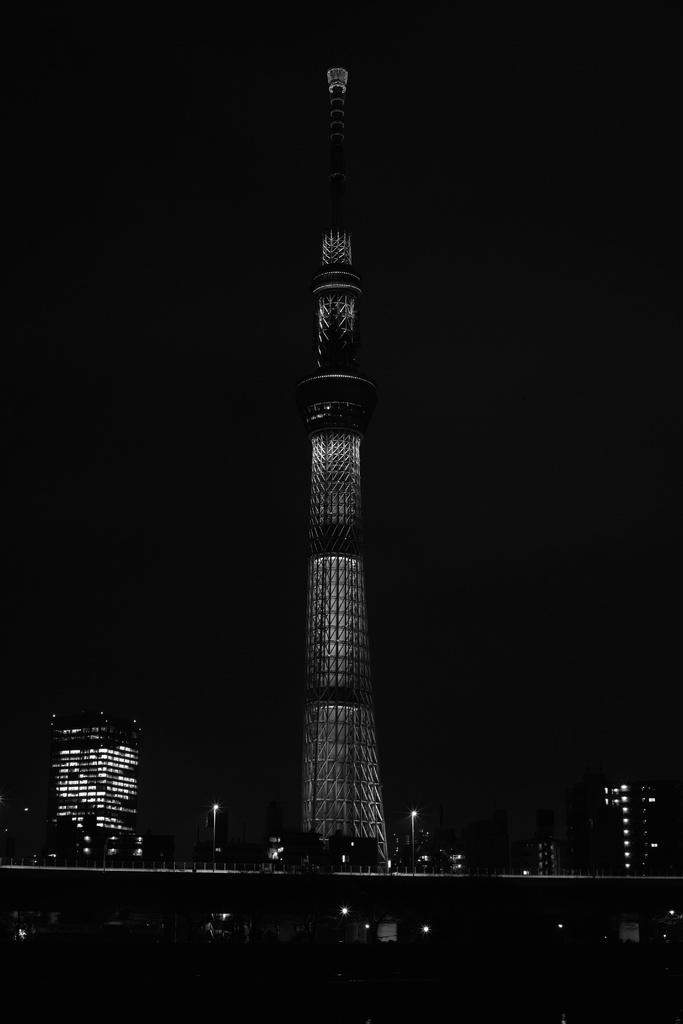What is the color scheme of the image? The image is black and white. What is the main subject in the image? There is a tall building in the image. What else can be seen in the background of the image? There are other buildings in the background of the image. What type of amusement can be seen in the image? There is no amusement present in the image; it features a tall building and other buildings in the background. Who is talking in the image? There are no people visible in the image, so it is not possible to determine who might be talking. 